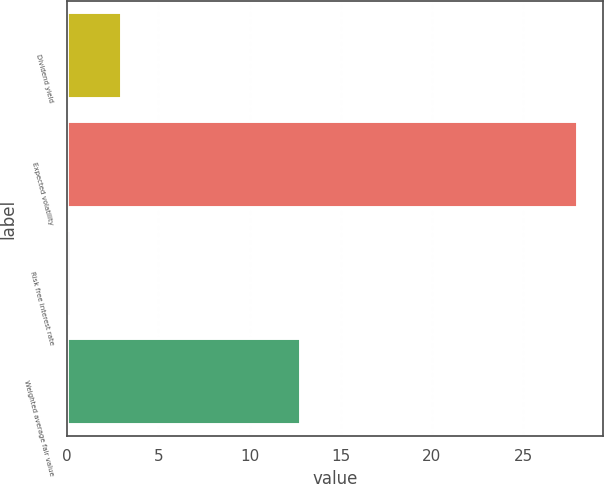Convert chart to OTSL. <chart><loc_0><loc_0><loc_500><loc_500><bar_chart><fcel>Dividend yield<fcel>Expected volatility<fcel>Risk free interest rate<fcel>Weighted average fair value<nl><fcel>2.98<fcel>28<fcel>0.2<fcel>12.83<nl></chart> 